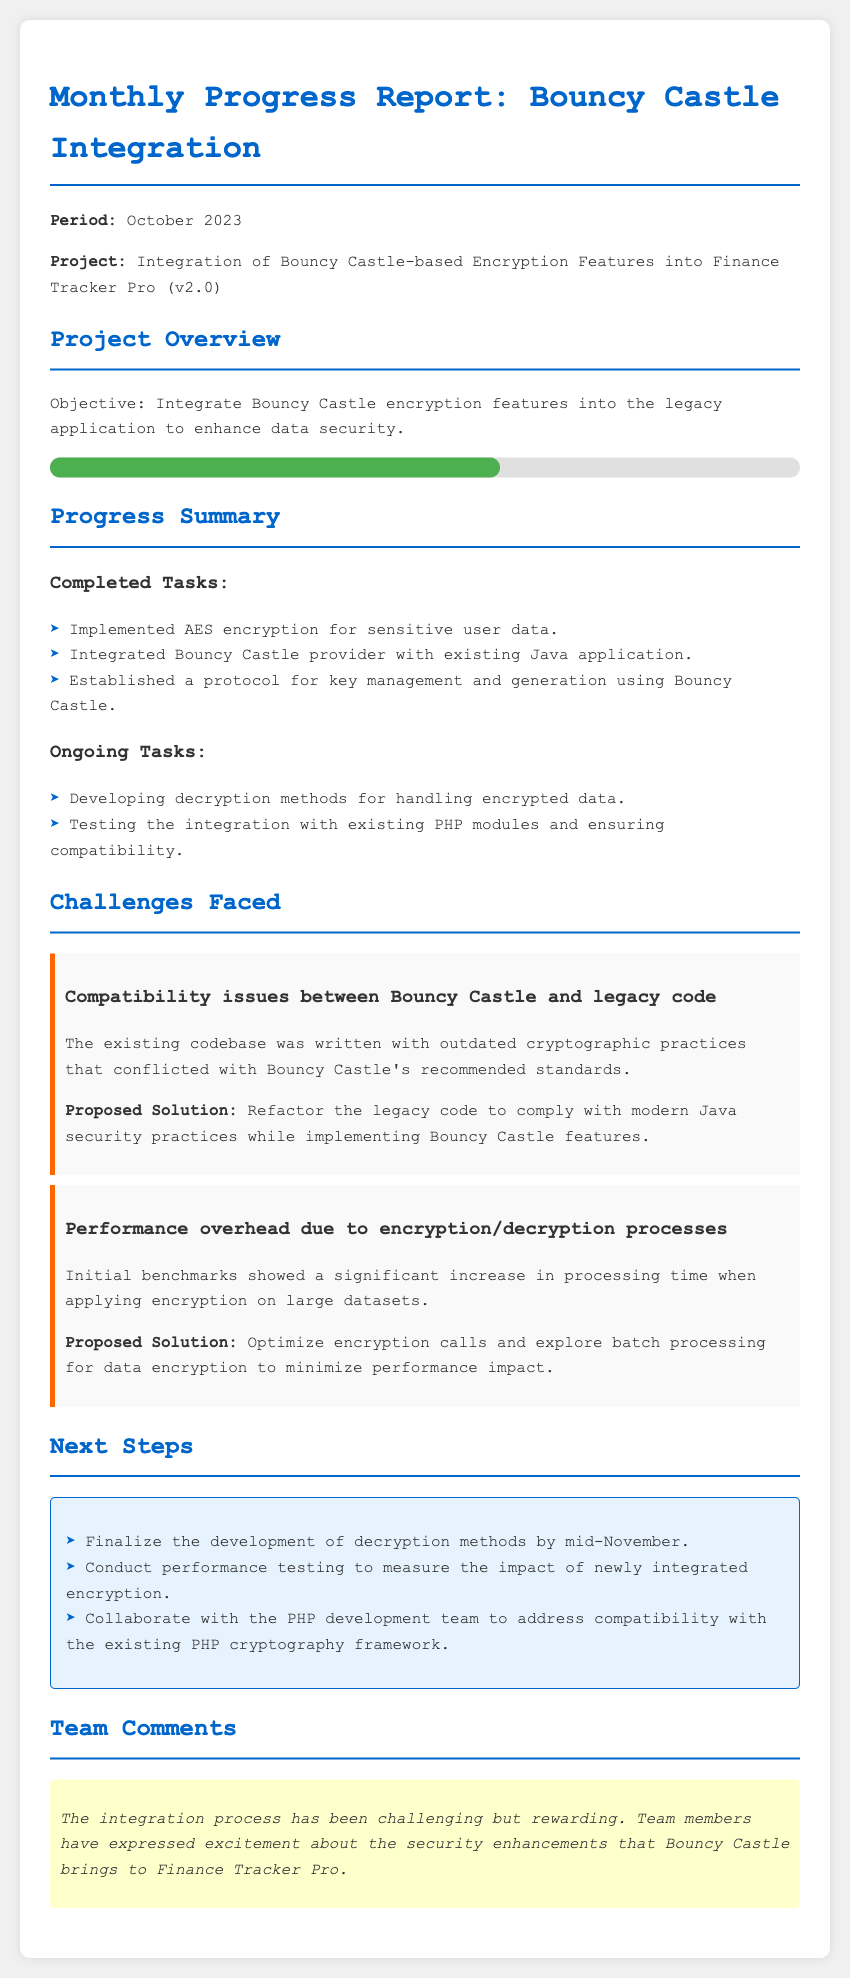what is the project period? The project period is specified in the document and is October 2023.
Answer: October 2023 what is the main objective of the project? The objective outlines the purpose of the integration, which is to enhance data security.
Answer: Enhance data security what percentage indicates the current project progress? The document shows a visual representation of project progress which is indicated to be 60%.
Answer: 60% which encryption method was implemented for sensitive user data? The completed tasks section mentions the encryption method used for sensitive data, which is specified in the document.
Answer: AES encryption what is one of the ongoing tasks mentioned? The ongoing tasks section lists tasks being worked on, one of which is crucial for the integration process.
Answer: Developing decryption methods what challenge was faced regarding performance? The document details a specific challenge related to performance during the encryption/decryption processes.
Answer: Performance overhead what solution was proposed for compatibility issues? The document outlines the proposed solution for compatibility challenges encountered with legacy code.
Answer: Refactor the legacy code when is the decryption methods development expected to be finalized? The next steps section indicates a timeline for finalizing the development of decryption methods.
Answer: Mid-November what comment is shared by the team regarding the integration process? The team comments section provides insight into the team's sentiment about the project integration efforts.
Answer: Challenging but rewarding 